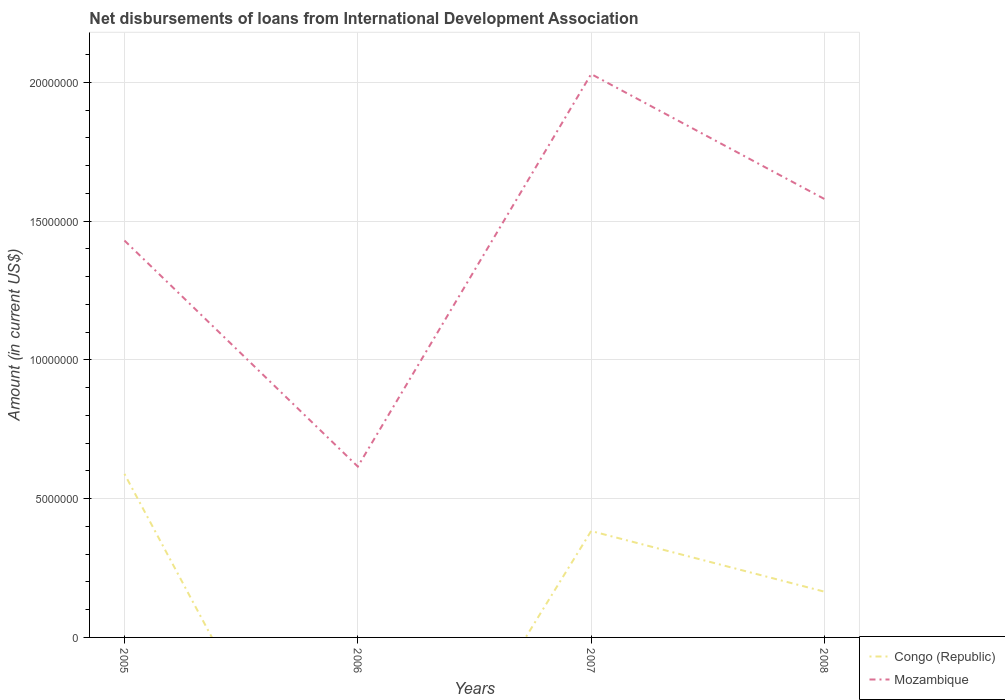Does the line corresponding to Mozambique intersect with the line corresponding to Congo (Republic)?
Your response must be concise. No. Across all years, what is the maximum amount of loans disbursed in Mozambique?
Your answer should be very brief. 6.16e+06. What is the total amount of loans disbursed in Mozambique in the graph?
Give a very brief answer. -9.64e+06. What is the difference between the highest and the second highest amount of loans disbursed in Congo (Republic)?
Provide a short and direct response. 5.89e+06. What is the difference between the highest and the lowest amount of loans disbursed in Congo (Republic)?
Provide a succinct answer. 2. Is the amount of loans disbursed in Mozambique strictly greater than the amount of loans disbursed in Congo (Republic) over the years?
Provide a short and direct response. No. Are the values on the major ticks of Y-axis written in scientific E-notation?
Provide a short and direct response. No. Does the graph contain any zero values?
Make the answer very short. Yes. Does the graph contain grids?
Keep it short and to the point. Yes. How are the legend labels stacked?
Ensure brevity in your answer.  Vertical. What is the title of the graph?
Your response must be concise. Net disbursements of loans from International Development Association. What is the label or title of the Y-axis?
Provide a short and direct response. Amount (in current US$). What is the Amount (in current US$) of Congo (Republic) in 2005?
Offer a very short reply. 5.89e+06. What is the Amount (in current US$) of Mozambique in 2005?
Ensure brevity in your answer.  1.43e+07. What is the Amount (in current US$) of Congo (Republic) in 2006?
Offer a terse response. 0. What is the Amount (in current US$) of Mozambique in 2006?
Offer a terse response. 6.16e+06. What is the Amount (in current US$) in Congo (Republic) in 2007?
Your answer should be compact. 3.83e+06. What is the Amount (in current US$) of Mozambique in 2007?
Make the answer very short. 2.03e+07. What is the Amount (in current US$) of Congo (Republic) in 2008?
Keep it short and to the point. 1.65e+06. What is the Amount (in current US$) of Mozambique in 2008?
Your answer should be very brief. 1.58e+07. Across all years, what is the maximum Amount (in current US$) in Congo (Republic)?
Offer a very short reply. 5.89e+06. Across all years, what is the maximum Amount (in current US$) in Mozambique?
Your answer should be very brief. 2.03e+07. Across all years, what is the minimum Amount (in current US$) in Congo (Republic)?
Make the answer very short. 0. Across all years, what is the minimum Amount (in current US$) in Mozambique?
Give a very brief answer. 6.16e+06. What is the total Amount (in current US$) of Congo (Republic) in the graph?
Your answer should be very brief. 1.14e+07. What is the total Amount (in current US$) in Mozambique in the graph?
Keep it short and to the point. 5.66e+07. What is the difference between the Amount (in current US$) of Mozambique in 2005 and that in 2006?
Make the answer very short. 8.14e+06. What is the difference between the Amount (in current US$) in Congo (Republic) in 2005 and that in 2007?
Offer a terse response. 2.06e+06. What is the difference between the Amount (in current US$) of Mozambique in 2005 and that in 2007?
Provide a short and direct response. -6.00e+06. What is the difference between the Amount (in current US$) in Congo (Republic) in 2005 and that in 2008?
Offer a terse response. 4.24e+06. What is the difference between the Amount (in current US$) of Mozambique in 2005 and that in 2008?
Your answer should be compact. -1.50e+06. What is the difference between the Amount (in current US$) in Mozambique in 2006 and that in 2007?
Your response must be concise. -1.41e+07. What is the difference between the Amount (in current US$) in Mozambique in 2006 and that in 2008?
Your response must be concise. -9.64e+06. What is the difference between the Amount (in current US$) in Congo (Republic) in 2007 and that in 2008?
Offer a terse response. 2.19e+06. What is the difference between the Amount (in current US$) in Mozambique in 2007 and that in 2008?
Give a very brief answer. 4.50e+06. What is the difference between the Amount (in current US$) of Congo (Republic) in 2005 and the Amount (in current US$) of Mozambique in 2006?
Keep it short and to the point. -2.65e+05. What is the difference between the Amount (in current US$) of Congo (Republic) in 2005 and the Amount (in current US$) of Mozambique in 2007?
Your answer should be compact. -1.44e+07. What is the difference between the Amount (in current US$) of Congo (Republic) in 2005 and the Amount (in current US$) of Mozambique in 2008?
Your answer should be very brief. -9.91e+06. What is the difference between the Amount (in current US$) of Congo (Republic) in 2007 and the Amount (in current US$) of Mozambique in 2008?
Keep it short and to the point. -1.20e+07. What is the average Amount (in current US$) in Congo (Republic) per year?
Offer a very short reply. 2.84e+06. What is the average Amount (in current US$) of Mozambique per year?
Your answer should be compact. 1.41e+07. In the year 2005, what is the difference between the Amount (in current US$) of Congo (Republic) and Amount (in current US$) of Mozambique?
Offer a very short reply. -8.41e+06. In the year 2007, what is the difference between the Amount (in current US$) of Congo (Republic) and Amount (in current US$) of Mozambique?
Your response must be concise. -1.65e+07. In the year 2008, what is the difference between the Amount (in current US$) in Congo (Republic) and Amount (in current US$) in Mozambique?
Keep it short and to the point. -1.42e+07. What is the ratio of the Amount (in current US$) in Mozambique in 2005 to that in 2006?
Provide a succinct answer. 2.32. What is the ratio of the Amount (in current US$) in Congo (Republic) in 2005 to that in 2007?
Provide a short and direct response. 1.54. What is the ratio of the Amount (in current US$) of Mozambique in 2005 to that in 2007?
Provide a short and direct response. 0.7. What is the ratio of the Amount (in current US$) in Congo (Republic) in 2005 to that in 2008?
Provide a short and direct response. 3.58. What is the ratio of the Amount (in current US$) in Mozambique in 2005 to that in 2008?
Give a very brief answer. 0.91. What is the ratio of the Amount (in current US$) in Mozambique in 2006 to that in 2007?
Provide a succinct answer. 0.3. What is the ratio of the Amount (in current US$) in Mozambique in 2006 to that in 2008?
Provide a succinct answer. 0.39. What is the ratio of the Amount (in current US$) in Congo (Republic) in 2007 to that in 2008?
Give a very brief answer. 2.33. What is the ratio of the Amount (in current US$) of Mozambique in 2007 to that in 2008?
Your response must be concise. 1.28. What is the difference between the highest and the second highest Amount (in current US$) in Congo (Republic)?
Provide a short and direct response. 2.06e+06. What is the difference between the highest and the second highest Amount (in current US$) in Mozambique?
Offer a very short reply. 4.50e+06. What is the difference between the highest and the lowest Amount (in current US$) of Congo (Republic)?
Your response must be concise. 5.89e+06. What is the difference between the highest and the lowest Amount (in current US$) of Mozambique?
Give a very brief answer. 1.41e+07. 